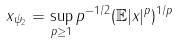Convert formula to latex. <formula><loc_0><loc_0><loc_500><loc_500>\| x \| _ { \psi _ { 2 } } & = \sup _ { p \geq 1 } p ^ { - 1 / 2 } ( \mathbb { E } | x | ^ { p } ) ^ { 1 / p }</formula> 